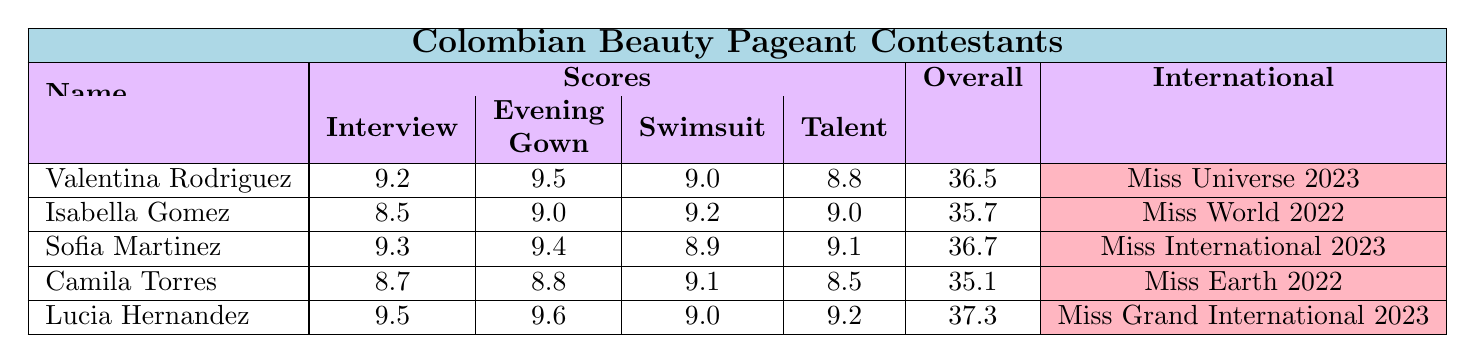What's the highest Overall Score among the contestants? By looking at the Overall Score column, I see that Lucia Hernandez has the highest score of 37.3.
Answer: 37.3 Which contestant has the lowest score in the Interview category? Checking the Interview scores, Isabella Gomez has the lowest score of 8.5.
Answer: 8.5 Are there any contestants who have won a Special Award for Best Evening Gown? By inspecting the Special Awards, both Sofia Martinez and Lucia Hernandez received the Best in Evening Gown award.
Answer: Yes What is the average Overall Score of all contestants? Adding all Overall Scores: 36.5 + 35.7 + 36.7 + 35.1 + 37.3 = 181.3. There are 5 contestants, so the average is 181.3 / 5 = 36.26.
Answer: 36.26 Which contestant has the tallest height? Looking at the Height column, Lucia Hernandez is the tallest at 5'9".
Answer: 5'9" Is there a contestant who participated in Miss Universe? Checking the International Experience, Valentina Rodriguez participated in Miss Universe 2023.
Answer: Yes What is the difference between the highest and lowest scores in the Swimsuit category? The highest score in Swimsuit is Valentina Rodriguez with 9.0 and the lowest is Camila Torres with 9.1. The difference is 9.1 - 8.9 = 0.2.
Answer: 0.2 How many contestants have an Overall Score above 36? The contestants with an Overall Score above 36 are Valentina Rodriguez, Sofia Martinez, and Lucia Hernandez. That’s a total of 3 contestants.
Answer: 3 Which contestant has the best score in Talent, and what is that score? By checking the Talent scores, Lucia Hernandez has the best score of 9.2.
Answer: Lucia Hernandez, 9.2 Do any contestants have the same score in the Evening Gown category? Checking the Evening Gown scores, I see that Sofia Martinez has 9.4 and Isabella Gomez has 9.0, which means no contestants have the same Evening Gown score.
Answer: No 